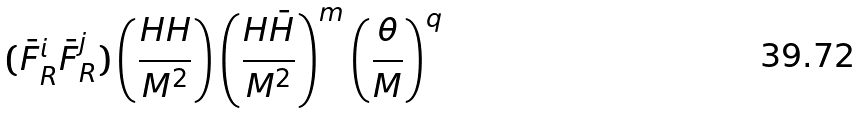Convert formula to latex. <formula><loc_0><loc_0><loc_500><loc_500>( \bar { F } ^ { i } _ { R } \bar { F } ^ { j } _ { R } ) \left ( \frac { H H } { M ^ { 2 } } \right ) \left ( \frac { H \bar { H } } { M ^ { 2 } } \right ) ^ { m } \left ( \frac { \theta } { M } \right ) ^ { q }</formula> 